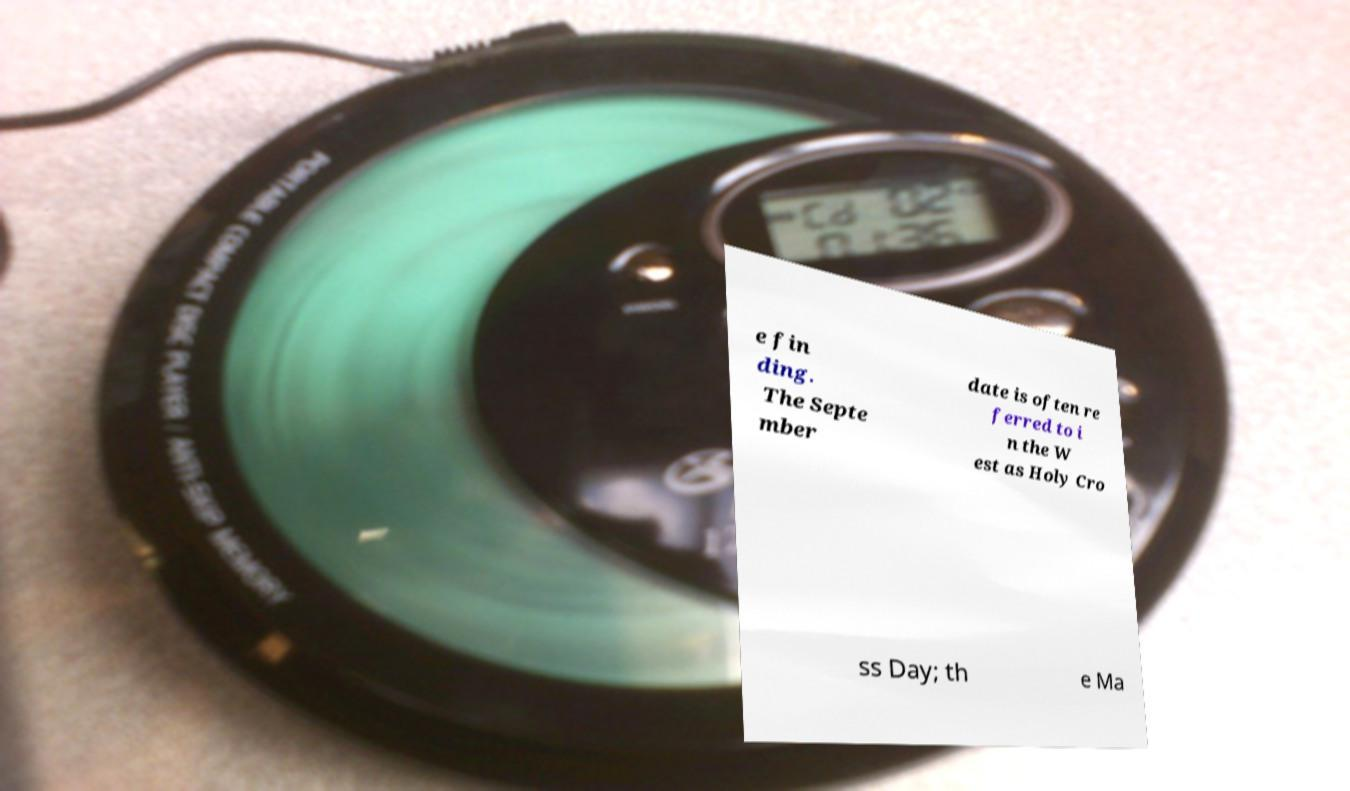Can you accurately transcribe the text from the provided image for me? e fin ding. The Septe mber date is often re ferred to i n the W est as Holy Cro ss Day; th e Ma 